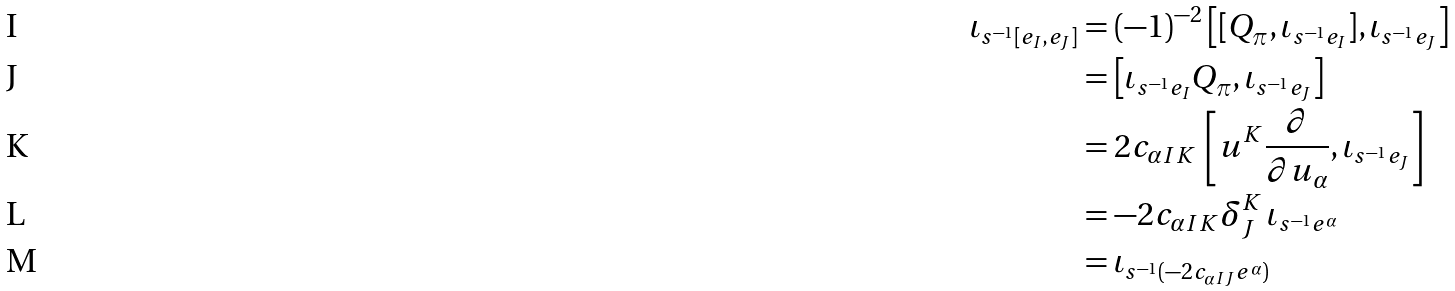Convert formula to latex. <formula><loc_0><loc_0><loc_500><loc_500>\iota _ { s ^ { - 1 } [ e _ { I } , e _ { J } ] } & = ( - 1 ) ^ { - 2 } \left [ [ Q _ { \pi } , \iota _ { s ^ { - 1 } e _ { I } } ] , \iota _ { s ^ { - 1 } e _ { J } } \right ] \\ & = \left [ \iota _ { s ^ { - 1 } e _ { I } } Q _ { \pi } , \iota _ { s ^ { - 1 } e _ { J } } \right ] \\ & = 2 c _ { \alpha I K } \, \left [ u ^ { K } \frac { \partial } { \partial u _ { \alpha } } , \iota _ { s ^ { - 1 } e _ { J } } \right ] \\ & = - 2 c _ { \alpha I K } \delta ^ { K } _ { J } \, \iota _ { s ^ { - 1 } e ^ { \alpha } } \\ & = \iota _ { s ^ { - 1 } ( - 2 c _ { \alpha I J } e ^ { \alpha } ) }</formula> 